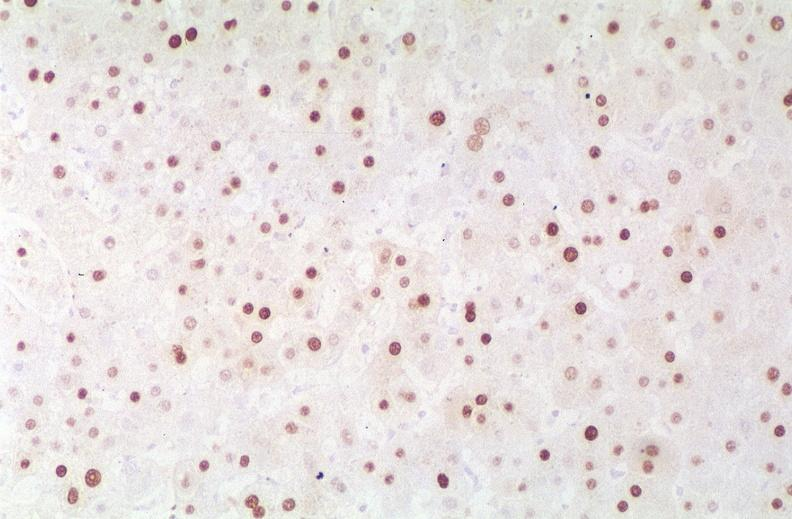what is present?
Answer the question using a single word or phrase. Liver 